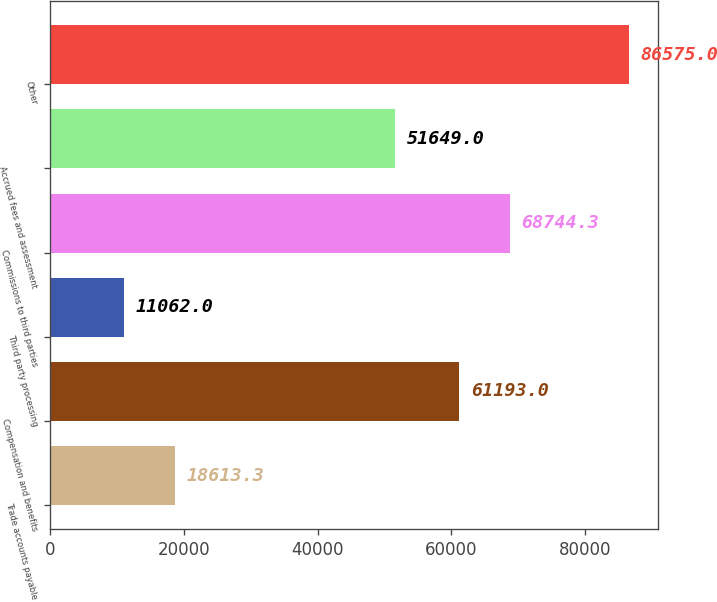Convert chart. <chart><loc_0><loc_0><loc_500><loc_500><bar_chart><fcel>Trade accounts payable<fcel>Compensation and benefits<fcel>Third party processing<fcel>Commissions to third parties<fcel>Accrued fees and assessment<fcel>Other<nl><fcel>18613.3<fcel>61193<fcel>11062<fcel>68744.3<fcel>51649<fcel>86575<nl></chart> 